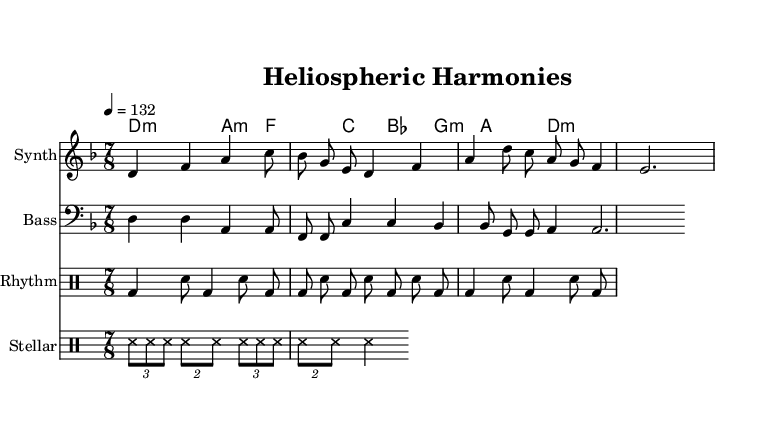What is the key signature of this music? The key signature is indicated at the beginning of the score. It shows two flats, which corresponds to D minor.
Answer: D minor What is the time signature of this music? The time signature appears after the key signature, represented by the fraction shown. It indicates that there are seven eighth notes per measure, which is displayed as 7/8.
Answer: 7/8 What is the tempo marking for this piece? The tempo is indicated as a number followed by an equal sign, shown at the beginning of the score. It specifies the speed at which the piece should be played, stated as 4 = 132.
Answer: 132 What is the rhythmic pattern used in the drum staff? By examining the drum staff, the first rhythmic section shows a combination of bass drum (bd) and snare drum (sn) notes. The first measure indicates a pattern of one quarter and two eighth notes, leading to a division that follows the seven eighth note structure.
Answer: Bass and snare How many measures are present in the melody? By counting the measures in the melody staff, we observe that there are a total of three measures, which consist of notes grouped together. Each measure is separated by a vertical line.
Answer: 3 What type of fusion is represented in this composition? The title of the piece provides direct insight into its genre and character. Additionally, the combination of traditional instruments with rhythmic elements representing stellar pulsations solidifies the nature of fusion.
Answer: Electronic-world fusion What unique rhythmic feature is found in the "stellar pulsation" section? In the stellar pulsation section, tuplet markings indicate irregular groupings of notes, specifically indicating groups of three and two notes. This feature creates complex rhythms mimicking the natural phenomena of stellar pulsations.
Answer: Tuplets 